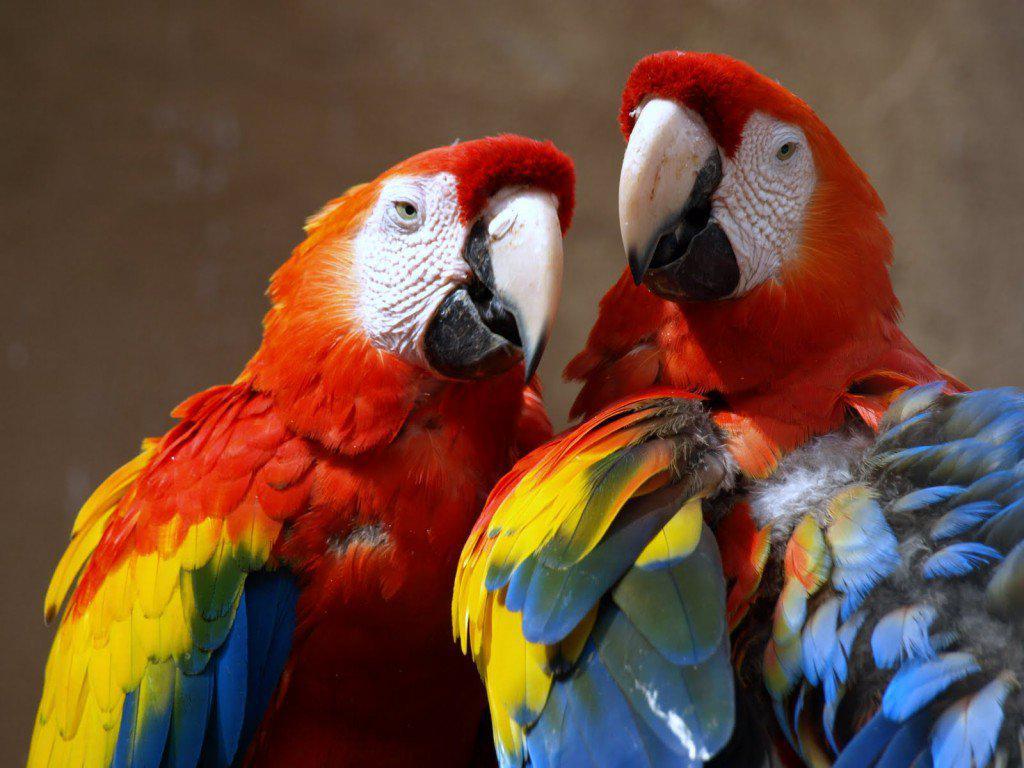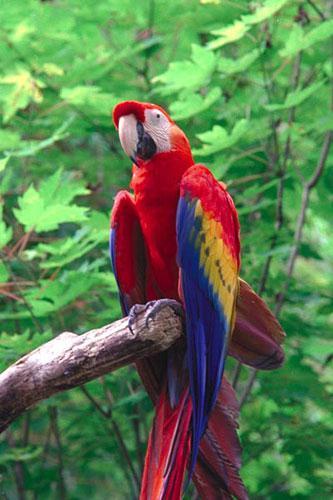The first image is the image on the left, the second image is the image on the right. Examine the images to the left and right. Is the description "There is exactly one parrot in the right image with a red head." accurate? Answer yes or no. Yes. The first image is the image on the left, the second image is the image on the right. For the images shown, is this caption "A total of three parrots are shown, and the left image contains two red-headed parrots." true? Answer yes or no. Yes. 